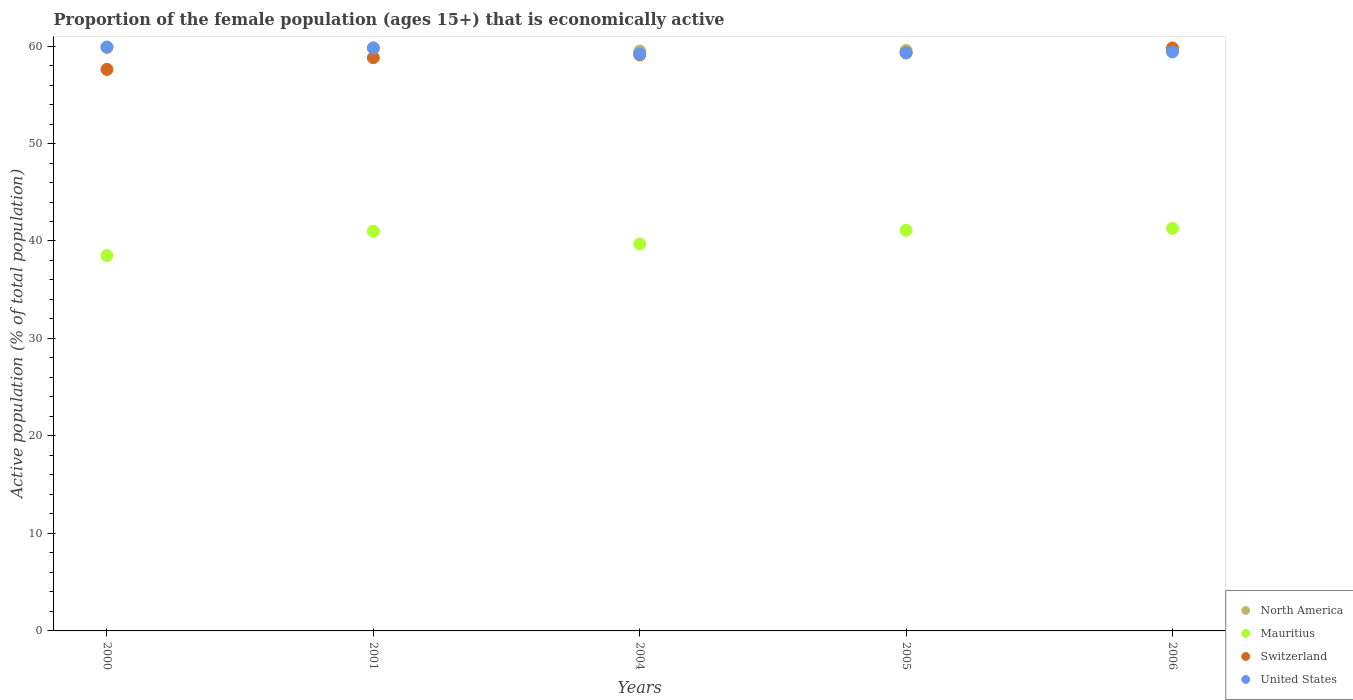How many different coloured dotlines are there?
Offer a very short reply. 4. What is the proportion of the female population that is economically active in North America in 2001?
Your response must be concise. 59.8. Across all years, what is the maximum proportion of the female population that is economically active in North America?
Give a very brief answer. 59.85. Across all years, what is the minimum proportion of the female population that is economically active in Mauritius?
Offer a terse response. 38.5. In which year was the proportion of the female population that is economically active in Mauritius maximum?
Your response must be concise. 2006. In which year was the proportion of the female population that is economically active in Switzerland minimum?
Give a very brief answer. 2000. What is the total proportion of the female population that is economically active in Mauritius in the graph?
Your response must be concise. 201.6. What is the difference between the proportion of the female population that is economically active in Mauritius in 2005 and that in 2006?
Ensure brevity in your answer.  -0.2. What is the difference between the proportion of the female population that is economically active in United States in 2004 and the proportion of the female population that is economically active in Switzerland in 2000?
Make the answer very short. 1.6. What is the average proportion of the female population that is economically active in Mauritius per year?
Provide a short and direct response. 40.32. In the year 2000, what is the difference between the proportion of the female population that is economically active in Mauritius and proportion of the female population that is economically active in North America?
Provide a succinct answer. -21.35. In how many years, is the proportion of the female population that is economically active in United States greater than 32 %?
Offer a terse response. 5. What is the ratio of the proportion of the female population that is economically active in Mauritius in 2004 to that in 2006?
Provide a succinct answer. 0.96. Is the difference between the proportion of the female population that is economically active in Mauritius in 2005 and 2006 greater than the difference between the proportion of the female population that is economically active in North America in 2005 and 2006?
Your answer should be compact. No. What is the difference between the highest and the second highest proportion of the female population that is economically active in Mauritius?
Provide a short and direct response. 0.2. What is the difference between the highest and the lowest proportion of the female population that is economically active in United States?
Keep it short and to the point. 0.7. Is it the case that in every year, the sum of the proportion of the female population that is economically active in United States and proportion of the female population that is economically active in North America  is greater than the sum of proportion of the female population that is economically active in Mauritius and proportion of the female population that is economically active in Switzerland?
Ensure brevity in your answer.  No. Does the proportion of the female population that is economically active in Switzerland monotonically increase over the years?
Make the answer very short. Yes. How many years are there in the graph?
Make the answer very short. 5. Are the values on the major ticks of Y-axis written in scientific E-notation?
Offer a very short reply. No. Does the graph contain grids?
Provide a succinct answer. No. Where does the legend appear in the graph?
Give a very brief answer. Bottom right. How many legend labels are there?
Your answer should be compact. 4. What is the title of the graph?
Provide a short and direct response. Proportion of the female population (ages 15+) that is economically active. Does "Mali" appear as one of the legend labels in the graph?
Ensure brevity in your answer.  No. What is the label or title of the X-axis?
Your response must be concise. Years. What is the label or title of the Y-axis?
Provide a short and direct response. Active population (% of total population). What is the Active population (% of total population) of North America in 2000?
Your answer should be compact. 59.85. What is the Active population (% of total population) in Mauritius in 2000?
Give a very brief answer. 38.5. What is the Active population (% of total population) in Switzerland in 2000?
Provide a succinct answer. 57.6. What is the Active population (% of total population) in United States in 2000?
Make the answer very short. 59.9. What is the Active population (% of total population) of North America in 2001?
Make the answer very short. 59.8. What is the Active population (% of total population) in Mauritius in 2001?
Provide a short and direct response. 41. What is the Active population (% of total population) in Switzerland in 2001?
Ensure brevity in your answer.  58.8. What is the Active population (% of total population) of United States in 2001?
Your response must be concise. 59.8. What is the Active population (% of total population) in North America in 2004?
Make the answer very short. 59.48. What is the Active population (% of total population) of Mauritius in 2004?
Your answer should be compact. 39.7. What is the Active population (% of total population) in Switzerland in 2004?
Offer a terse response. 59.1. What is the Active population (% of total population) of United States in 2004?
Offer a terse response. 59.2. What is the Active population (% of total population) in North America in 2005?
Offer a very short reply. 59.54. What is the Active population (% of total population) of Mauritius in 2005?
Your response must be concise. 41.1. What is the Active population (% of total population) of Switzerland in 2005?
Provide a succinct answer. 59.3. What is the Active population (% of total population) in United States in 2005?
Provide a short and direct response. 59.3. What is the Active population (% of total population) in North America in 2006?
Keep it short and to the point. 59.65. What is the Active population (% of total population) of Mauritius in 2006?
Offer a terse response. 41.3. What is the Active population (% of total population) in Switzerland in 2006?
Your answer should be compact. 59.8. What is the Active population (% of total population) in United States in 2006?
Offer a very short reply. 59.4. Across all years, what is the maximum Active population (% of total population) in North America?
Provide a short and direct response. 59.85. Across all years, what is the maximum Active population (% of total population) of Mauritius?
Keep it short and to the point. 41.3. Across all years, what is the maximum Active population (% of total population) of Switzerland?
Make the answer very short. 59.8. Across all years, what is the maximum Active population (% of total population) of United States?
Ensure brevity in your answer.  59.9. Across all years, what is the minimum Active population (% of total population) of North America?
Offer a very short reply. 59.48. Across all years, what is the minimum Active population (% of total population) in Mauritius?
Ensure brevity in your answer.  38.5. Across all years, what is the minimum Active population (% of total population) in Switzerland?
Make the answer very short. 57.6. Across all years, what is the minimum Active population (% of total population) in United States?
Your answer should be very brief. 59.2. What is the total Active population (% of total population) in North America in the graph?
Make the answer very short. 298.33. What is the total Active population (% of total population) of Mauritius in the graph?
Offer a terse response. 201.6. What is the total Active population (% of total population) in Switzerland in the graph?
Provide a short and direct response. 294.6. What is the total Active population (% of total population) of United States in the graph?
Offer a very short reply. 297.6. What is the difference between the Active population (% of total population) in North America in 2000 and that in 2001?
Provide a succinct answer. 0.05. What is the difference between the Active population (% of total population) of Switzerland in 2000 and that in 2001?
Your answer should be very brief. -1.2. What is the difference between the Active population (% of total population) of United States in 2000 and that in 2001?
Ensure brevity in your answer.  0.1. What is the difference between the Active population (% of total population) in North America in 2000 and that in 2004?
Provide a succinct answer. 0.37. What is the difference between the Active population (% of total population) of Switzerland in 2000 and that in 2004?
Provide a succinct answer. -1.5. What is the difference between the Active population (% of total population) in North America in 2000 and that in 2005?
Your answer should be very brief. 0.31. What is the difference between the Active population (% of total population) of Mauritius in 2000 and that in 2005?
Provide a succinct answer. -2.6. What is the difference between the Active population (% of total population) of North America in 2000 and that in 2006?
Provide a succinct answer. 0.2. What is the difference between the Active population (% of total population) of Switzerland in 2000 and that in 2006?
Keep it short and to the point. -2.2. What is the difference between the Active population (% of total population) of United States in 2000 and that in 2006?
Offer a very short reply. 0.5. What is the difference between the Active population (% of total population) in North America in 2001 and that in 2004?
Provide a short and direct response. 0.32. What is the difference between the Active population (% of total population) in Switzerland in 2001 and that in 2004?
Offer a very short reply. -0.3. What is the difference between the Active population (% of total population) in North America in 2001 and that in 2005?
Provide a succinct answer. 0.26. What is the difference between the Active population (% of total population) of Switzerland in 2001 and that in 2005?
Provide a succinct answer. -0.5. What is the difference between the Active population (% of total population) of United States in 2001 and that in 2005?
Make the answer very short. 0.5. What is the difference between the Active population (% of total population) of North America in 2001 and that in 2006?
Keep it short and to the point. 0.15. What is the difference between the Active population (% of total population) of Switzerland in 2001 and that in 2006?
Provide a short and direct response. -1. What is the difference between the Active population (% of total population) in United States in 2001 and that in 2006?
Provide a short and direct response. 0.4. What is the difference between the Active population (% of total population) in North America in 2004 and that in 2005?
Your answer should be very brief. -0.06. What is the difference between the Active population (% of total population) of Mauritius in 2004 and that in 2005?
Your answer should be very brief. -1.4. What is the difference between the Active population (% of total population) of Switzerland in 2004 and that in 2005?
Offer a very short reply. -0.2. What is the difference between the Active population (% of total population) of North America in 2004 and that in 2006?
Give a very brief answer. -0.17. What is the difference between the Active population (% of total population) in Switzerland in 2004 and that in 2006?
Provide a short and direct response. -0.7. What is the difference between the Active population (% of total population) of United States in 2004 and that in 2006?
Give a very brief answer. -0.2. What is the difference between the Active population (% of total population) of North America in 2005 and that in 2006?
Your response must be concise. -0.11. What is the difference between the Active population (% of total population) in Switzerland in 2005 and that in 2006?
Your answer should be compact. -0.5. What is the difference between the Active population (% of total population) of United States in 2005 and that in 2006?
Your answer should be very brief. -0.1. What is the difference between the Active population (% of total population) in North America in 2000 and the Active population (% of total population) in Mauritius in 2001?
Your answer should be compact. 18.85. What is the difference between the Active population (% of total population) in North America in 2000 and the Active population (% of total population) in Switzerland in 2001?
Offer a very short reply. 1.05. What is the difference between the Active population (% of total population) of North America in 2000 and the Active population (% of total population) of United States in 2001?
Your answer should be very brief. 0.05. What is the difference between the Active population (% of total population) in Mauritius in 2000 and the Active population (% of total population) in Switzerland in 2001?
Provide a short and direct response. -20.3. What is the difference between the Active population (% of total population) in Mauritius in 2000 and the Active population (% of total population) in United States in 2001?
Make the answer very short. -21.3. What is the difference between the Active population (% of total population) of Switzerland in 2000 and the Active population (% of total population) of United States in 2001?
Provide a short and direct response. -2.2. What is the difference between the Active population (% of total population) in North America in 2000 and the Active population (% of total population) in Mauritius in 2004?
Your response must be concise. 20.15. What is the difference between the Active population (% of total population) in North America in 2000 and the Active population (% of total population) in Switzerland in 2004?
Your response must be concise. 0.75. What is the difference between the Active population (% of total population) of North America in 2000 and the Active population (% of total population) of United States in 2004?
Ensure brevity in your answer.  0.65. What is the difference between the Active population (% of total population) in Mauritius in 2000 and the Active population (% of total population) in Switzerland in 2004?
Provide a succinct answer. -20.6. What is the difference between the Active population (% of total population) in Mauritius in 2000 and the Active population (% of total population) in United States in 2004?
Provide a succinct answer. -20.7. What is the difference between the Active population (% of total population) of North America in 2000 and the Active population (% of total population) of Mauritius in 2005?
Provide a short and direct response. 18.75. What is the difference between the Active population (% of total population) of North America in 2000 and the Active population (% of total population) of Switzerland in 2005?
Your answer should be compact. 0.55. What is the difference between the Active population (% of total population) in North America in 2000 and the Active population (% of total population) in United States in 2005?
Your response must be concise. 0.55. What is the difference between the Active population (% of total population) of Mauritius in 2000 and the Active population (% of total population) of Switzerland in 2005?
Provide a short and direct response. -20.8. What is the difference between the Active population (% of total population) of Mauritius in 2000 and the Active population (% of total population) of United States in 2005?
Your response must be concise. -20.8. What is the difference between the Active population (% of total population) in North America in 2000 and the Active population (% of total population) in Mauritius in 2006?
Offer a very short reply. 18.55. What is the difference between the Active population (% of total population) in North America in 2000 and the Active population (% of total population) in Switzerland in 2006?
Keep it short and to the point. 0.05. What is the difference between the Active population (% of total population) in North America in 2000 and the Active population (% of total population) in United States in 2006?
Provide a succinct answer. 0.45. What is the difference between the Active population (% of total population) in Mauritius in 2000 and the Active population (% of total population) in Switzerland in 2006?
Offer a very short reply. -21.3. What is the difference between the Active population (% of total population) in Mauritius in 2000 and the Active population (% of total population) in United States in 2006?
Give a very brief answer. -20.9. What is the difference between the Active population (% of total population) of Switzerland in 2000 and the Active population (% of total population) of United States in 2006?
Give a very brief answer. -1.8. What is the difference between the Active population (% of total population) of North America in 2001 and the Active population (% of total population) of Mauritius in 2004?
Ensure brevity in your answer.  20.1. What is the difference between the Active population (% of total population) of North America in 2001 and the Active population (% of total population) of Switzerland in 2004?
Keep it short and to the point. 0.7. What is the difference between the Active population (% of total population) in Mauritius in 2001 and the Active population (% of total population) in Switzerland in 2004?
Ensure brevity in your answer.  -18.1. What is the difference between the Active population (% of total population) of Mauritius in 2001 and the Active population (% of total population) of United States in 2004?
Your response must be concise. -18.2. What is the difference between the Active population (% of total population) of North America in 2001 and the Active population (% of total population) of Mauritius in 2005?
Ensure brevity in your answer.  18.7. What is the difference between the Active population (% of total population) in Mauritius in 2001 and the Active population (% of total population) in Switzerland in 2005?
Give a very brief answer. -18.3. What is the difference between the Active population (% of total population) in Mauritius in 2001 and the Active population (% of total population) in United States in 2005?
Make the answer very short. -18.3. What is the difference between the Active population (% of total population) of Switzerland in 2001 and the Active population (% of total population) of United States in 2005?
Provide a short and direct response. -0.5. What is the difference between the Active population (% of total population) in North America in 2001 and the Active population (% of total population) in Mauritius in 2006?
Ensure brevity in your answer.  18.5. What is the difference between the Active population (% of total population) in North America in 2001 and the Active population (% of total population) in United States in 2006?
Offer a terse response. 0.4. What is the difference between the Active population (% of total population) in Mauritius in 2001 and the Active population (% of total population) in Switzerland in 2006?
Your answer should be compact. -18.8. What is the difference between the Active population (% of total population) in Mauritius in 2001 and the Active population (% of total population) in United States in 2006?
Offer a terse response. -18.4. What is the difference between the Active population (% of total population) of Switzerland in 2001 and the Active population (% of total population) of United States in 2006?
Offer a terse response. -0.6. What is the difference between the Active population (% of total population) in North America in 2004 and the Active population (% of total population) in Mauritius in 2005?
Make the answer very short. 18.38. What is the difference between the Active population (% of total population) of North America in 2004 and the Active population (% of total population) of Switzerland in 2005?
Your response must be concise. 0.18. What is the difference between the Active population (% of total population) of North America in 2004 and the Active population (% of total population) of United States in 2005?
Keep it short and to the point. 0.18. What is the difference between the Active population (% of total population) of Mauritius in 2004 and the Active population (% of total population) of Switzerland in 2005?
Keep it short and to the point. -19.6. What is the difference between the Active population (% of total population) in Mauritius in 2004 and the Active population (% of total population) in United States in 2005?
Your answer should be very brief. -19.6. What is the difference between the Active population (% of total population) of Switzerland in 2004 and the Active population (% of total population) of United States in 2005?
Your answer should be compact. -0.2. What is the difference between the Active population (% of total population) of North America in 2004 and the Active population (% of total population) of Mauritius in 2006?
Make the answer very short. 18.18. What is the difference between the Active population (% of total population) of North America in 2004 and the Active population (% of total population) of Switzerland in 2006?
Your answer should be very brief. -0.32. What is the difference between the Active population (% of total population) of North America in 2004 and the Active population (% of total population) of United States in 2006?
Ensure brevity in your answer.  0.08. What is the difference between the Active population (% of total population) in Mauritius in 2004 and the Active population (% of total population) in Switzerland in 2006?
Your answer should be very brief. -20.1. What is the difference between the Active population (% of total population) of Mauritius in 2004 and the Active population (% of total population) of United States in 2006?
Your answer should be compact. -19.7. What is the difference between the Active population (% of total population) of North America in 2005 and the Active population (% of total population) of Mauritius in 2006?
Your answer should be compact. 18.24. What is the difference between the Active population (% of total population) in North America in 2005 and the Active population (% of total population) in Switzerland in 2006?
Keep it short and to the point. -0.26. What is the difference between the Active population (% of total population) of North America in 2005 and the Active population (% of total population) of United States in 2006?
Give a very brief answer. 0.14. What is the difference between the Active population (% of total population) of Mauritius in 2005 and the Active population (% of total population) of Switzerland in 2006?
Provide a short and direct response. -18.7. What is the difference between the Active population (% of total population) in Mauritius in 2005 and the Active population (% of total population) in United States in 2006?
Provide a succinct answer. -18.3. What is the average Active population (% of total population) of North America per year?
Provide a succinct answer. 59.67. What is the average Active population (% of total population) of Mauritius per year?
Your answer should be very brief. 40.32. What is the average Active population (% of total population) of Switzerland per year?
Offer a very short reply. 58.92. What is the average Active population (% of total population) in United States per year?
Your answer should be compact. 59.52. In the year 2000, what is the difference between the Active population (% of total population) in North America and Active population (% of total population) in Mauritius?
Offer a terse response. 21.35. In the year 2000, what is the difference between the Active population (% of total population) in North America and Active population (% of total population) in Switzerland?
Ensure brevity in your answer.  2.25. In the year 2000, what is the difference between the Active population (% of total population) in North America and Active population (% of total population) in United States?
Make the answer very short. -0.05. In the year 2000, what is the difference between the Active population (% of total population) of Mauritius and Active population (% of total population) of Switzerland?
Your answer should be compact. -19.1. In the year 2000, what is the difference between the Active population (% of total population) in Mauritius and Active population (% of total population) in United States?
Give a very brief answer. -21.4. In the year 2001, what is the difference between the Active population (% of total population) of North America and Active population (% of total population) of Mauritius?
Make the answer very short. 18.8. In the year 2001, what is the difference between the Active population (% of total population) of Mauritius and Active population (% of total population) of Switzerland?
Provide a succinct answer. -17.8. In the year 2001, what is the difference between the Active population (% of total population) of Mauritius and Active population (% of total population) of United States?
Your answer should be compact. -18.8. In the year 2004, what is the difference between the Active population (% of total population) in North America and Active population (% of total population) in Mauritius?
Offer a terse response. 19.78. In the year 2004, what is the difference between the Active population (% of total population) of North America and Active population (% of total population) of Switzerland?
Your response must be concise. 0.38. In the year 2004, what is the difference between the Active population (% of total population) of North America and Active population (% of total population) of United States?
Provide a short and direct response. 0.28. In the year 2004, what is the difference between the Active population (% of total population) of Mauritius and Active population (% of total population) of Switzerland?
Your answer should be very brief. -19.4. In the year 2004, what is the difference between the Active population (% of total population) in Mauritius and Active population (% of total population) in United States?
Provide a succinct answer. -19.5. In the year 2004, what is the difference between the Active population (% of total population) in Switzerland and Active population (% of total population) in United States?
Your answer should be compact. -0.1. In the year 2005, what is the difference between the Active population (% of total population) of North America and Active population (% of total population) of Mauritius?
Your answer should be very brief. 18.44. In the year 2005, what is the difference between the Active population (% of total population) in North America and Active population (% of total population) in Switzerland?
Give a very brief answer. 0.24. In the year 2005, what is the difference between the Active population (% of total population) in North America and Active population (% of total population) in United States?
Ensure brevity in your answer.  0.24. In the year 2005, what is the difference between the Active population (% of total population) in Mauritius and Active population (% of total population) in Switzerland?
Offer a terse response. -18.2. In the year 2005, what is the difference between the Active population (% of total population) of Mauritius and Active population (% of total population) of United States?
Provide a succinct answer. -18.2. In the year 2005, what is the difference between the Active population (% of total population) of Switzerland and Active population (% of total population) of United States?
Provide a short and direct response. 0. In the year 2006, what is the difference between the Active population (% of total population) in North America and Active population (% of total population) in Mauritius?
Your answer should be very brief. 18.35. In the year 2006, what is the difference between the Active population (% of total population) of North America and Active population (% of total population) of Switzerland?
Make the answer very short. -0.15. In the year 2006, what is the difference between the Active population (% of total population) of North America and Active population (% of total population) of United States?
Offer a terse response. 0.25. In the year 2006, what is the difference between the Active population (% of total population) in Mauritius and Active population (% of total population) in Switzerland?
Offer a terse response. -18.5. In the year 2006, what is the difference between the Active population (% of total population) in Mauritius and Active population (% of total population) in United States?
Keep it short and to the point. -18.1. What is the ratio of the Active population (% of total population) of North America in 2000 to that in 2001?
Provide a succinct answer. 1. What is the ratio of the Active population (% of total population) in Mauritius in 2000 to that in 2001?
Ensure brevity in your answer.  0.94. What is the ratio of the Active population (% of total population) of Switzerland in 2000 to that in 2001?
Your response must be concise. 0.98. What is the ratio of the Active population (% of total population) of Mauritius in 2000 to that in 2004?
Give a very brief answer. 0.97. What is the ratio of the Active population (% of total population) in Switzerland in 2000 to that in 2004?
Your response must be concise. 0.97. What is the ratio of the Active population (% of total population) of United States in 2000 to that in 2004?
Make the answer very short. 1.01. What is the ratio of the Active population (% of total population) in Mauritius in 2000 to that in 2005?
Make the answer very short. 0.94. What is the ratio of the Active population (% of total population) of Switzerland in 2000 to that in 2005?
Ensure brevity in your answer.  0.97. What is the ratio of the Active population (% of total population) in Mauritius in 2000 to that in 2006?
Your answer should be compact. 0.93. What is the ratio of the Active population (% of total population) in Switzerland in 2000 to that in 2006?
Offer a terse response. 0.96. What is the ratio of the Active population (% of total population) of United States in 2000 to that in 2006?
Provide a succinct answer. 1.01. What is the ratio of the Active population (% of total population) of North America in 2001 to that in 2004?
Keep it short and to the point. 1.01. What is the ratio of the Active population (% of total population) in Mauritius in 2001 to that in 2004?
Provide a short and direct response. 1.03. What is the ratio of the Active population (% of total population) of Switzerland in 2001 to that in 2004?
Make the answer very short. 0.99. What is the ratio of the Active population (% of total population) in North America in 2001 to that in 2005?
Provide a succinct answer. 1. What is the ratio of the Active population (% of total population) in Mauritius in 2001 to that in 2005?
Keep it short and to the point. 1. What is the ratio of the Active population (% of total population) in United States in 2001 to that in 2005?
Keep it short and to the point. 1.01. What is the ratio of the Active population (% of total population) of Switzerland in 2001 to that in 2006?
Your answer should be compact. 0.98. What is the ratio of the Active population (% of total population) in United States in 2001 to that in 2006?
Give a very brief answer. 1.01. What is the ratio of the Active population (% of total population) of Mauritius in 2004 to that in 2005?
Your answer should be very brief. 0.97. What is the ratio of the Active population (% of total population) in United States in 2004 to that in 2005?
Your answer should be very brief. 1. What is the ratio of the Active population (% of total population) of Mauritius in 2004 to that in 2006?
Make the answer very short. 0.96. What is the ratio of the Active population (% of total population) of Switzerland in 2004 to that in 2006?
Your answer should be compact. 0.99. What is the ratio of the Active population (% of total population) in North America in 2005 to that in 2006?
Provide a short and direct response. 1. What is the difference between the highest and the second highest Active population (% of total population) in North America?
Provide a succinct answer. 0.05. What is the difference between the highest and the second highest Active population (% of total population) in Switzerland?
Provide a succinct answer. 0.5. What is the difference between the highest and the second highest Active population (% of total population) of United States?
Offer a terse response. 0.1. What is the difference between the highest and the lowest Active population (% of total population) of North America?
Provide a short and direct response. 0.37. What is the difference between the highest and the lowest Active population (% of total population) in United States?
Offer a terse response. 0.7. 